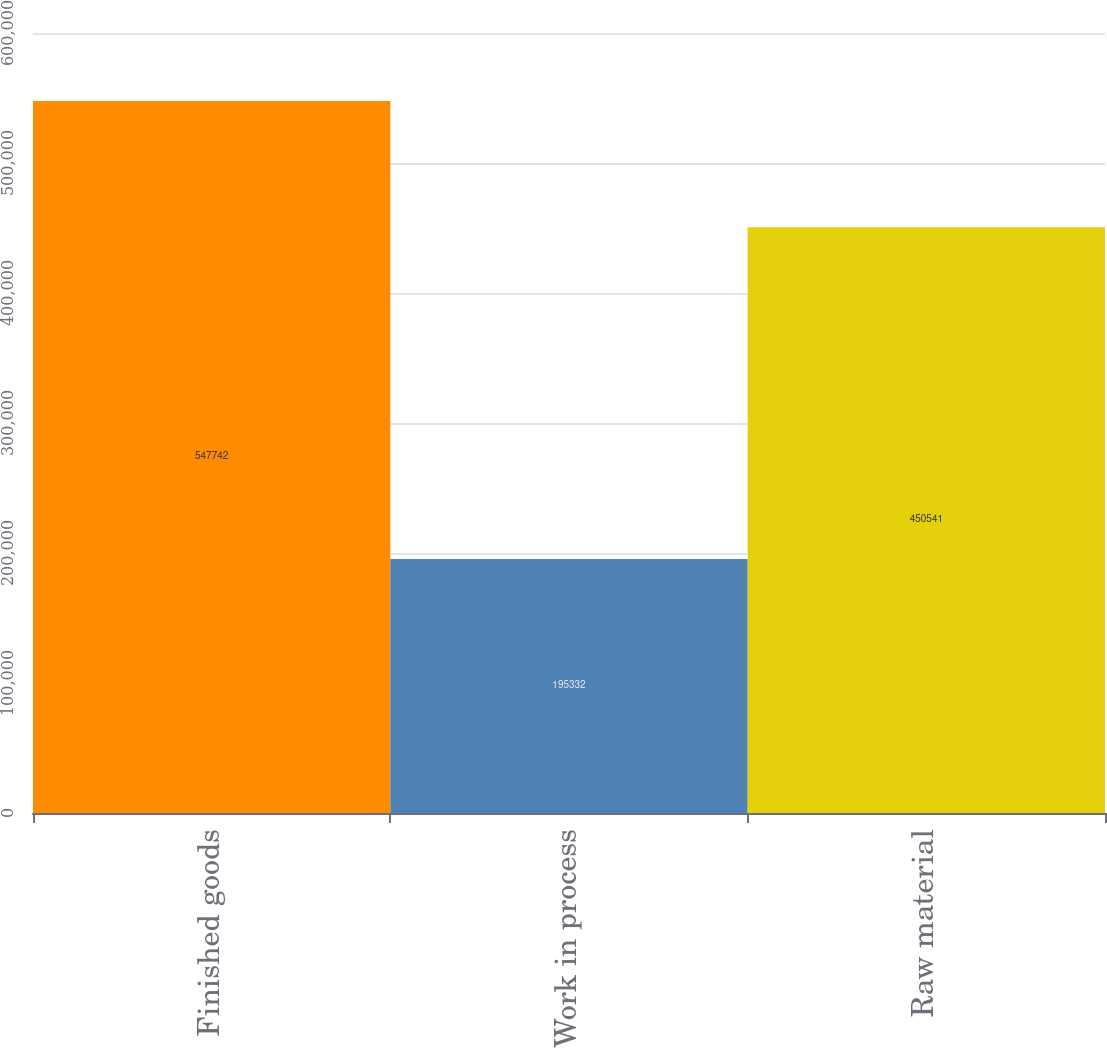<chart> <loc_0><loc_0><loc_500><loc_500><bar_chart><fcel>Finished goods<fcel>Work in process<fcel>Raw material<nl><fcel>547742<fcel>195332<fcel>450541<nl></chart> 